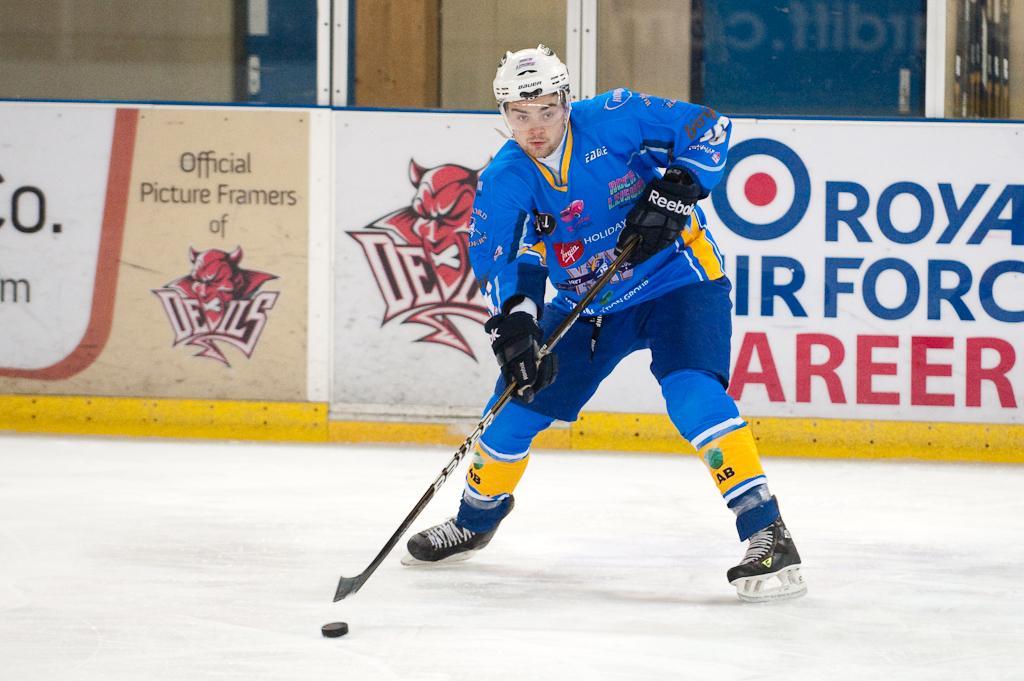Please provide a concise description of this image. In this picture we can see a person holding a hockey stick in his hands and wearing skate shoes on his legs. We can see a few posters at the back, from left to right. There is a watermark on the right side. 